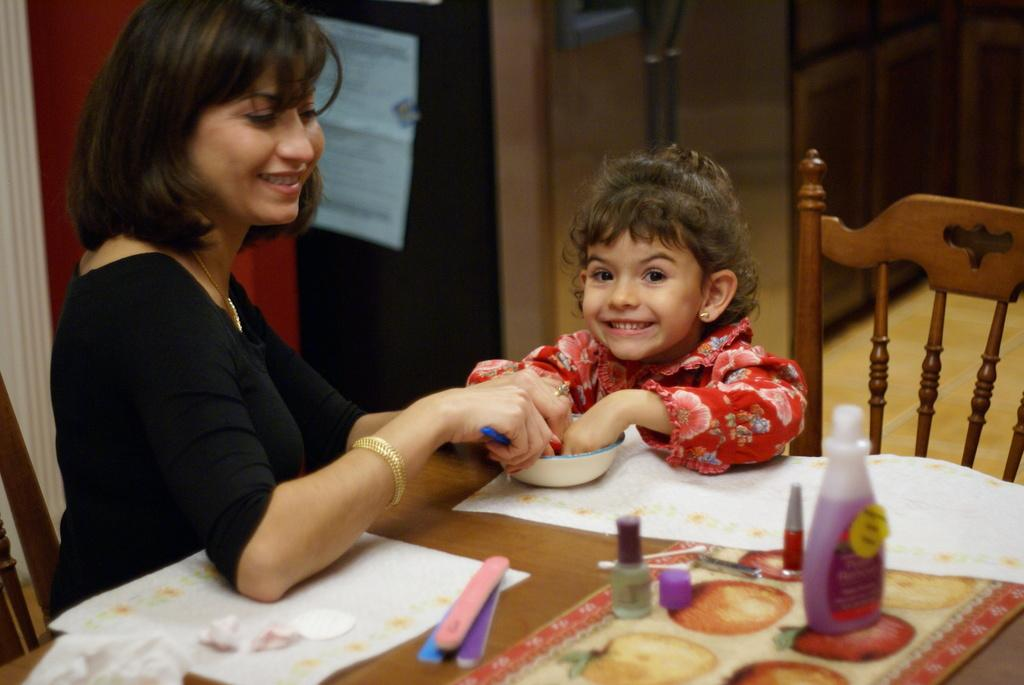Who is present in the image? There are women and a child in the image. What are the women and child doing? They are laughing in the image. Where are the women and child sitting? They are sitting on a chair. What can be seen in the background of the image? There is a table in the image. What is on the table? There are many objects on the table. What type of plastic bottle can be seen on the table in the image? There is no plastic bottle present on the table in the image. What type of soup is being served on the table in the image? There is no soup present on the table in the image. 